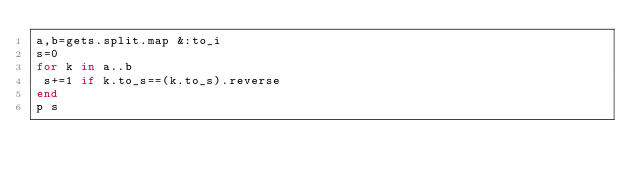<code> <loc_0><loc_0><loc_500><loc_500><_Ruby_>a,b=gets.split.map &:to_i
s=0
for k in a..b
 s+=1 if k.to_s==(k.to_s).reverse
end
p s</code> 